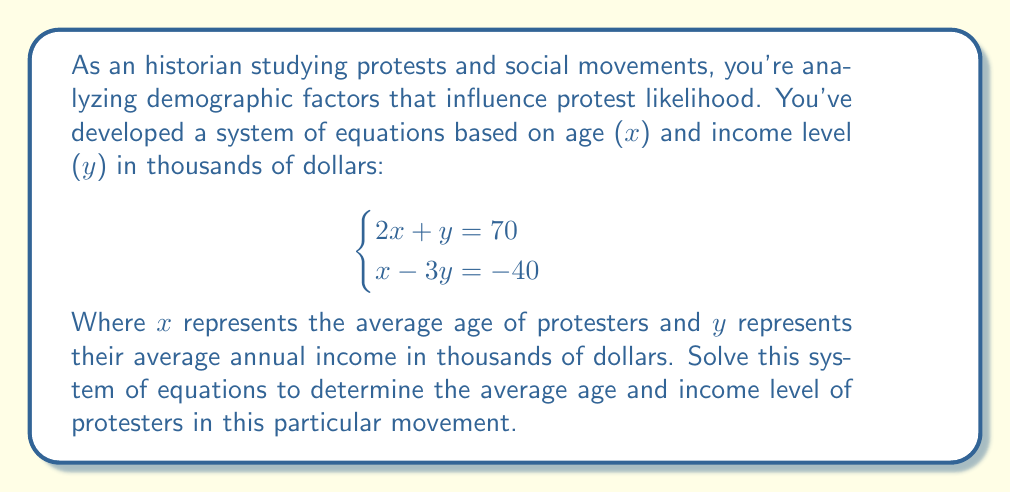Help me with this question. To solve this system of equations, we'll use the substitution method:

1) From the first equation, express y in terms of x:
   $$2x + y = 70$$
   $$y = 70 - 2x$$

2) Substitute this expression for y into the second equation:
   $$x - 3y = -40$$
   $$x - 3(70 - 2x) = -40$$

3) Simplify:
   $$x - 210 + 6x = -40$$
   $$7x - 210 = -40$$

4) Solve for x:
   $$7x = 170$$
   $$x = \frac{170}{7} \approx 24.29$$

5) Round x to the nearest whole number since age is typically expressed as a whole number:
   $$x = 24$$

6) Substitute this value of x back into the equation from step 1 to find y:
   $$y = 70 - 2(24)$$
   $$y = 70 - 48 = 22$$

Therefore, the average age of protesters is 24 years old, and their average annual income is $22,000.
Answer: The average age of protesters (x) is 24 years old, and their average annual income (y) is $22,000. 